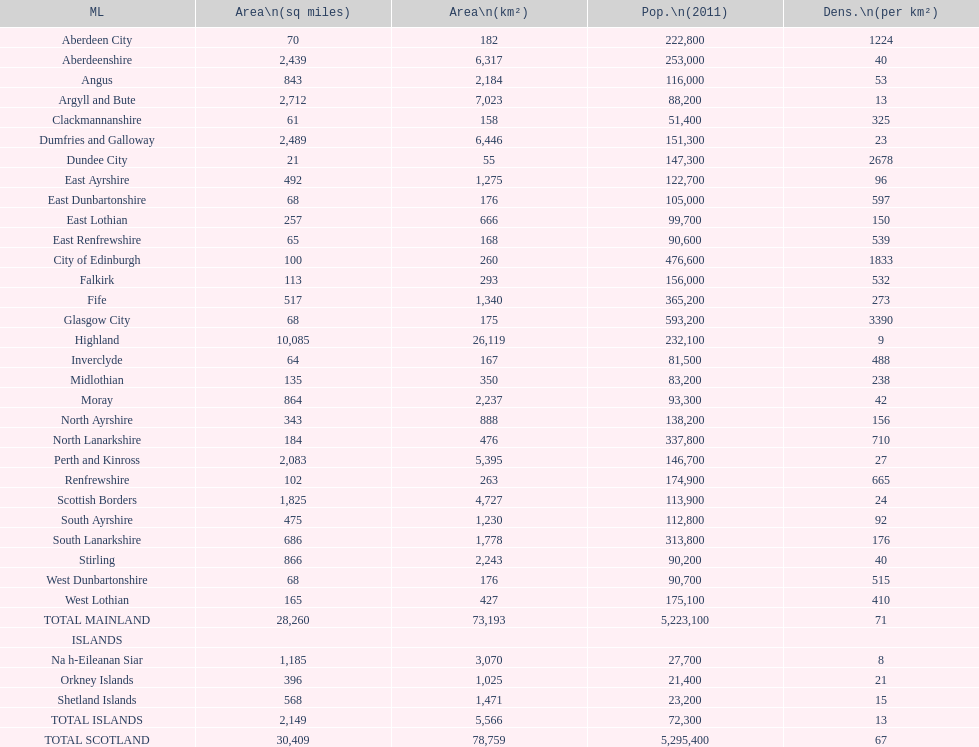Which mainland has the least population? Clackmannanshire. 